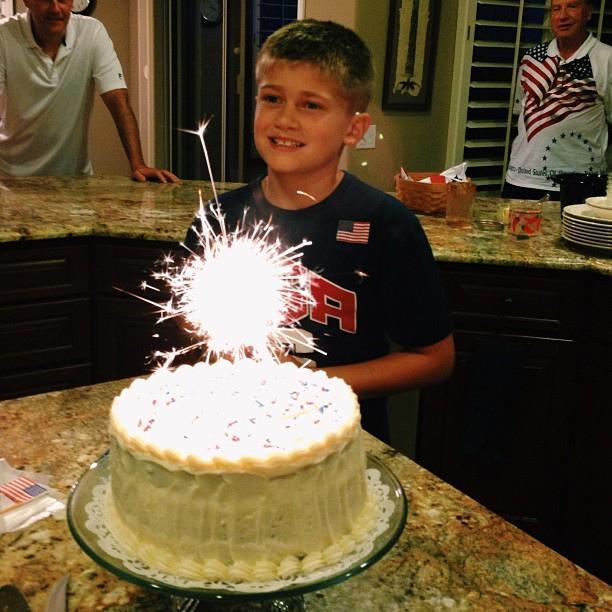What holiday is this cake likeliest to commemorate?
Indicate the correct response by choosing from the four available options to answer the question.
Options: Wedding, birthday, 4th july, anniversary. 4th july. 